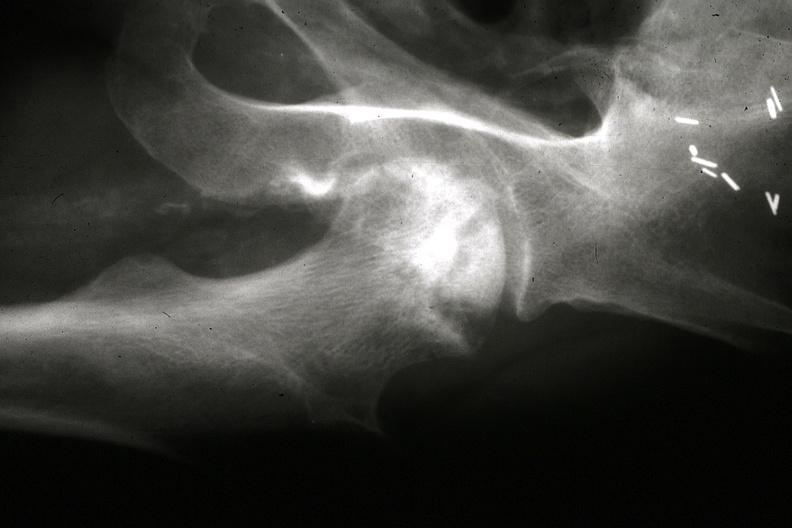what does this image show?
Answer the question using a single word or phrase. X-ray close-up of right femoral head from pelvic x-ray gross 